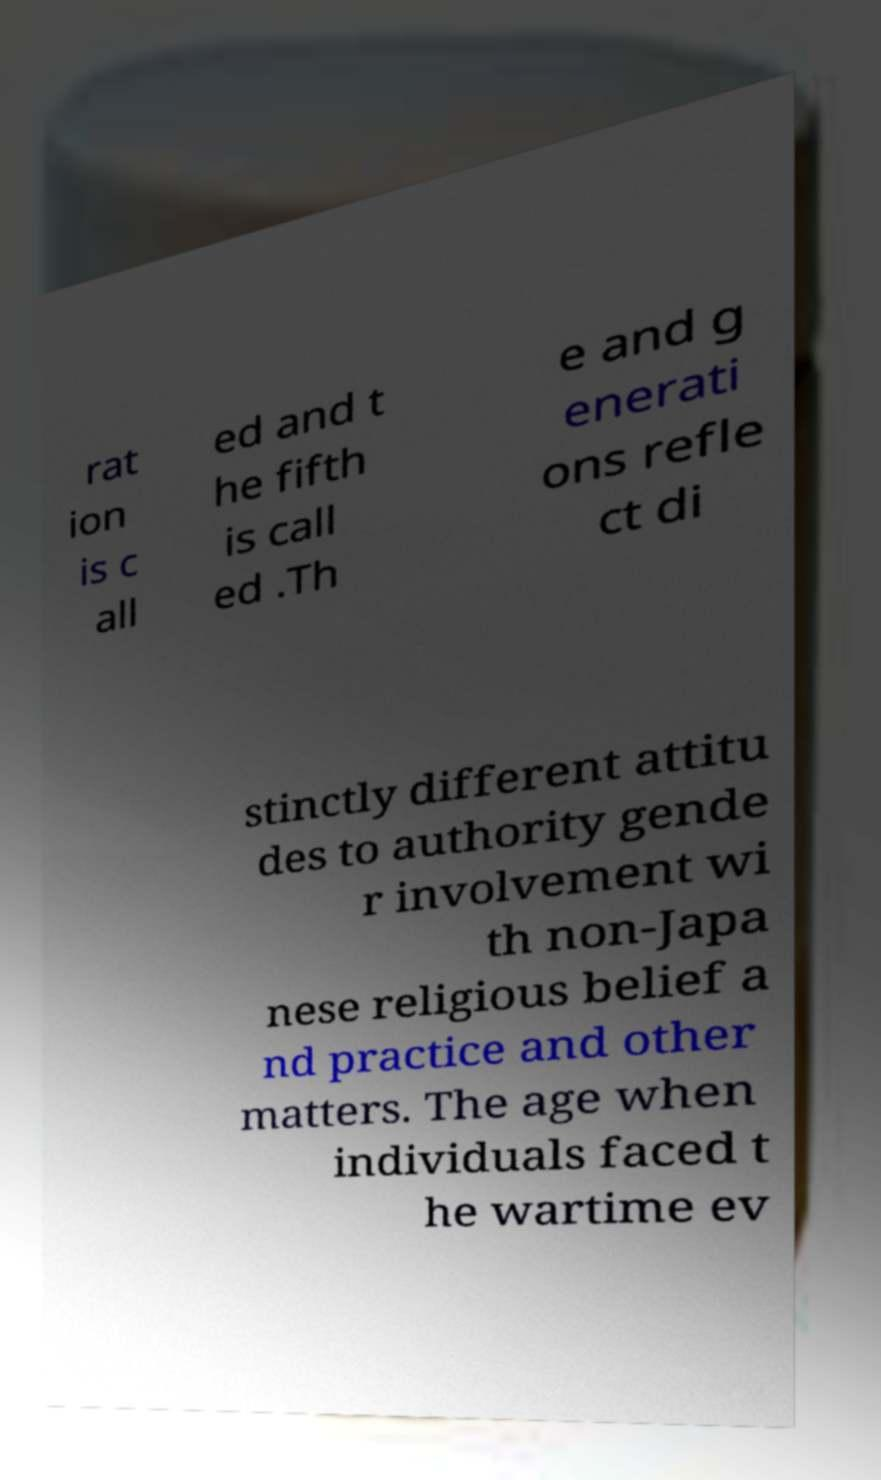Please read and relay the text visible in this image. What does it say? rat ion is c all ed and t he fifth is call ed .Th e and g enerati ons refle ct di stinctly different attitu des to authority gende r involvement wi th non-Japa nese religious belief a nd practice and other matters. The age when individuals faced t he wartime ev 